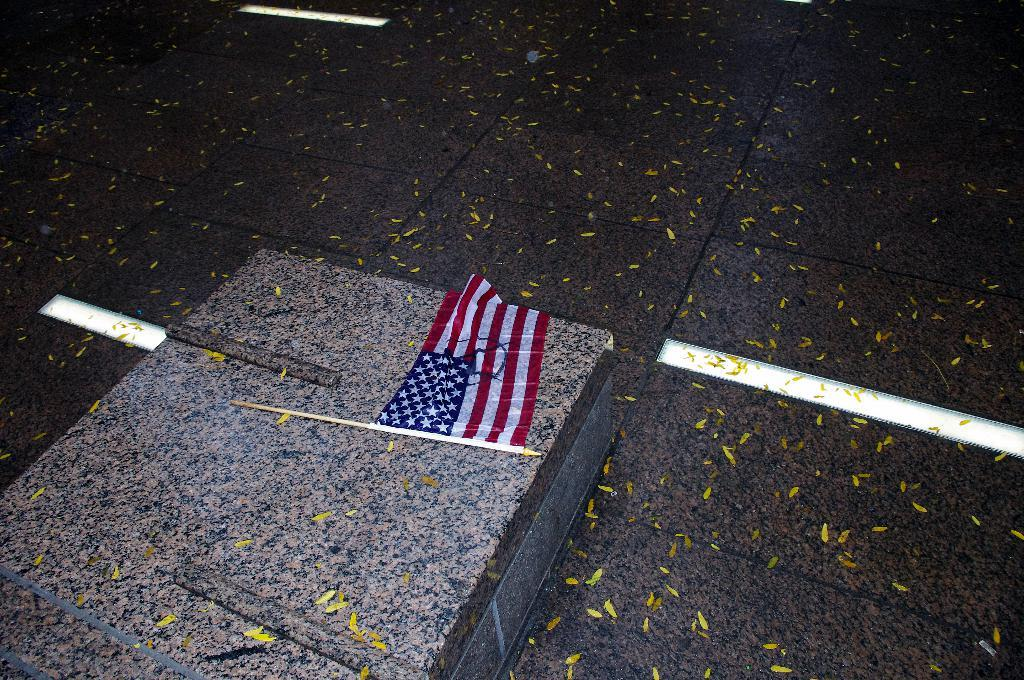What is the primary surface visible in the image? There is a floor in the image. What object can be seen on the floor? There is a marble on the floor. What is attached to the marble in the image? A flag is tied to a stick on the marble. What type of plastic material is used to make the flag in the image? There is no information about the flag's material in the image, so it cannot be determined if it is made of plastic. 